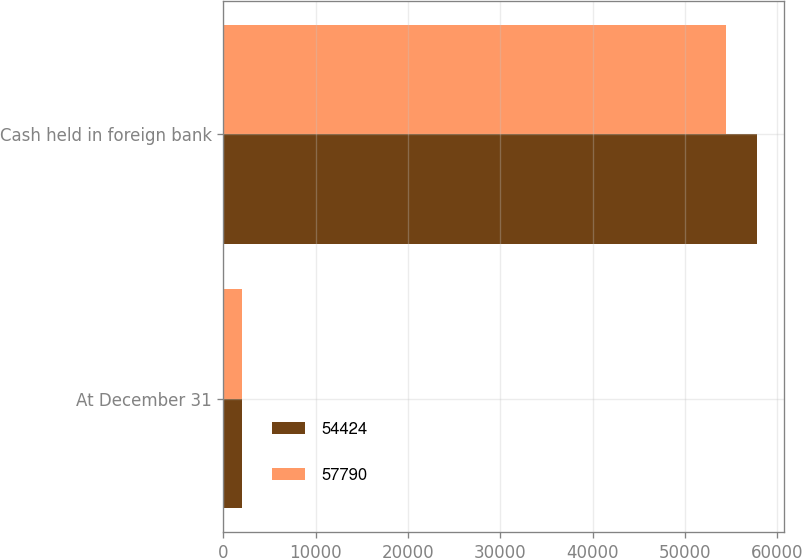<chart> <loc_0><loc_0><loc_500><loc_500><stacked_bar_chart><ecel><fcel>At December 31<fcel>Cash held in foreign bank<nl><fcel>54424<fcel>2017<fcel>57790<nl><fcel>57790<fcel>2016<fcel>54424<nl></chart> 